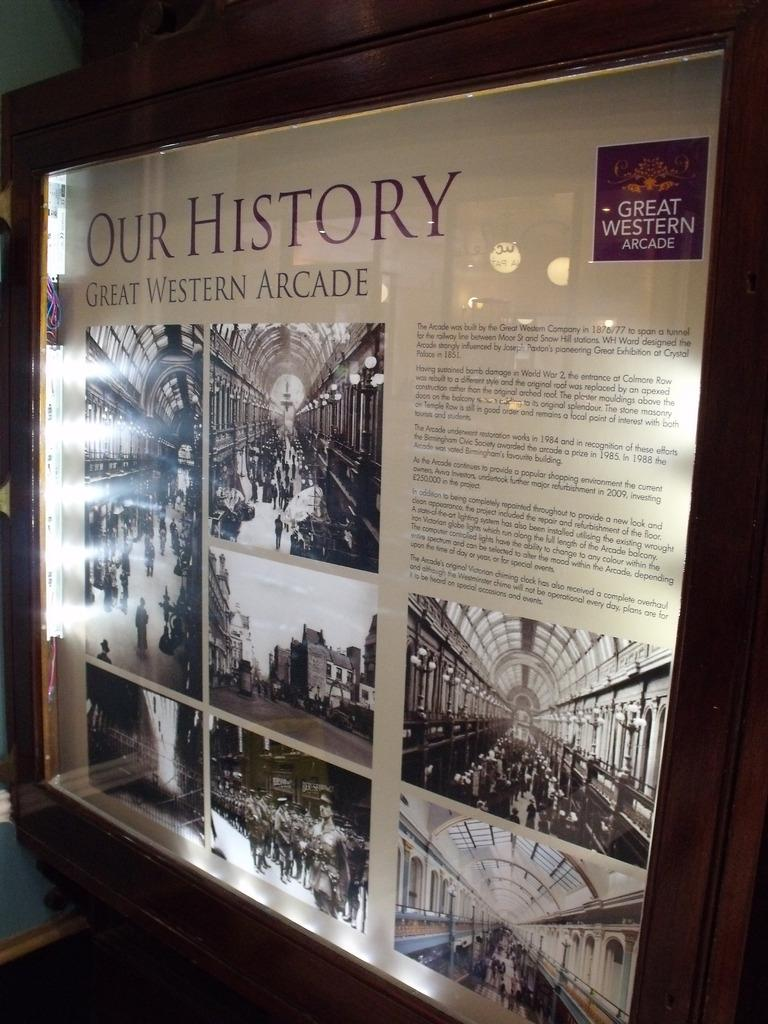Provide a one-sentence caption for the provided image. A poster of the Great Western Arcade which was built by the Great Western Company. 